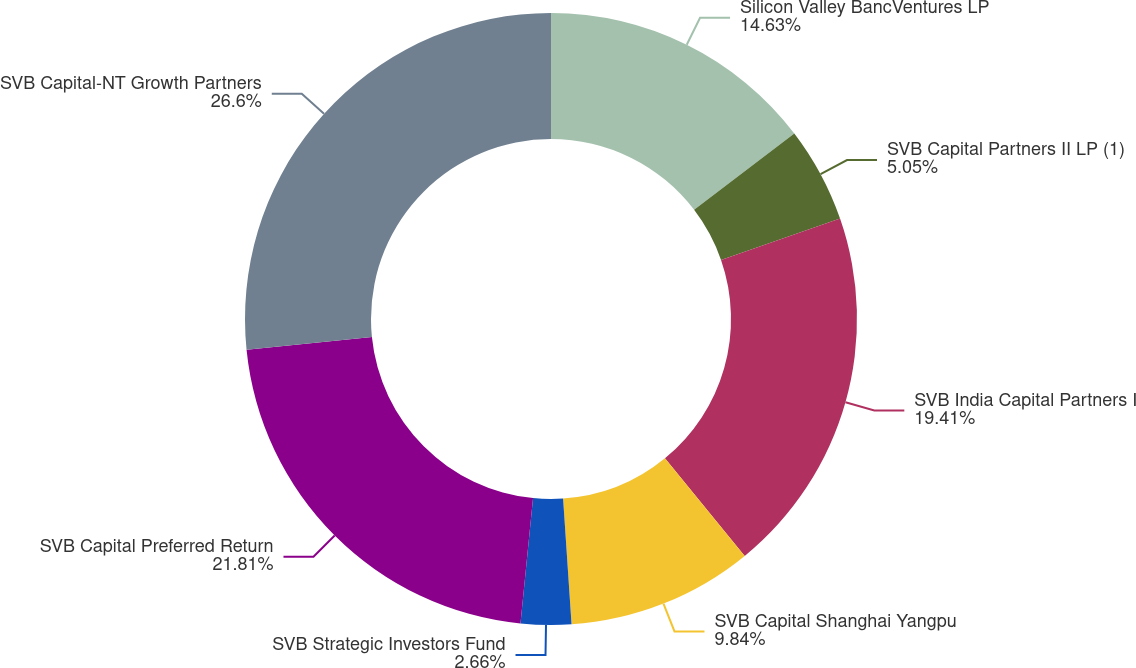Convert chart. <chart><loc_0><loc_0><loc_500><loc_500><pie_chart><fcel>Silicon Valley BancVentures LP<fcel>SVB Capital Partners II LP (1)<fcel>SVB India Capital Partners I<fcel>SVB Capital Shanghai Yangpu<fcel>SVB Strategic Investors Fund<fcel>SVB Capital Preferred Return<fcel>SVB Capital-NT Growth Partners<nl><fcel>14.63%<fcel>5.05%<fcel>19.41%<fcel>9.84%<fcel>2.66%<fcel>21.81%<fcel>26.6%<nl></chart> 